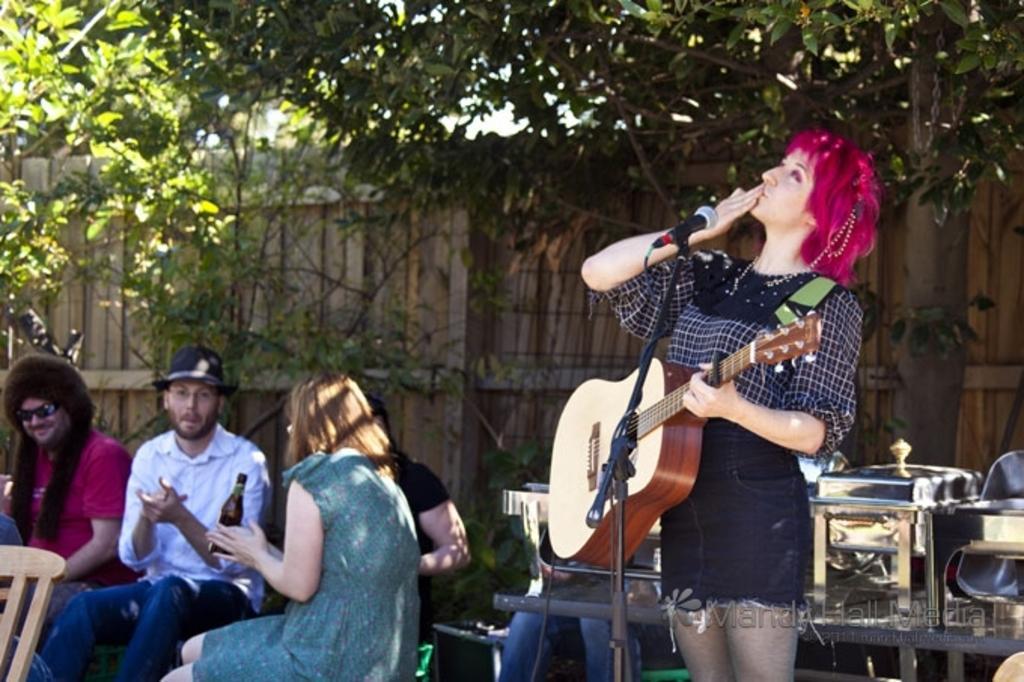Can you describe this image briefly? In this image I see 5 persons and in which 4 of them are sitting and one of them over here is holding a guitar and she is standing in front of a mic. In the background I can see the fence, few plants, a tree and the utensils. 